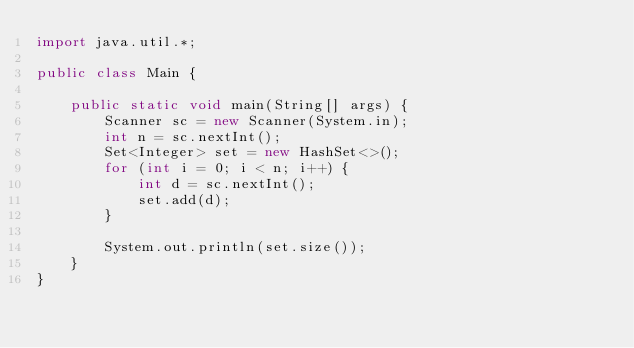Convert code to text. <code><loc_0><loc_0><loc_500><loc_500><_Java_>import java.util.*;

public class Main {

    public static void main(String[] args) {
        Scanner sc = new Scanner(System.in);
        int n = sc.nextInt();
        Set<Integer> set = new HashSet<>();
        for (int i = 0; i < n; i++) {
            int d = sc.nextInt();
            set.add(d);
        }

        System.out.println(set.size());
    }
}
</code> 